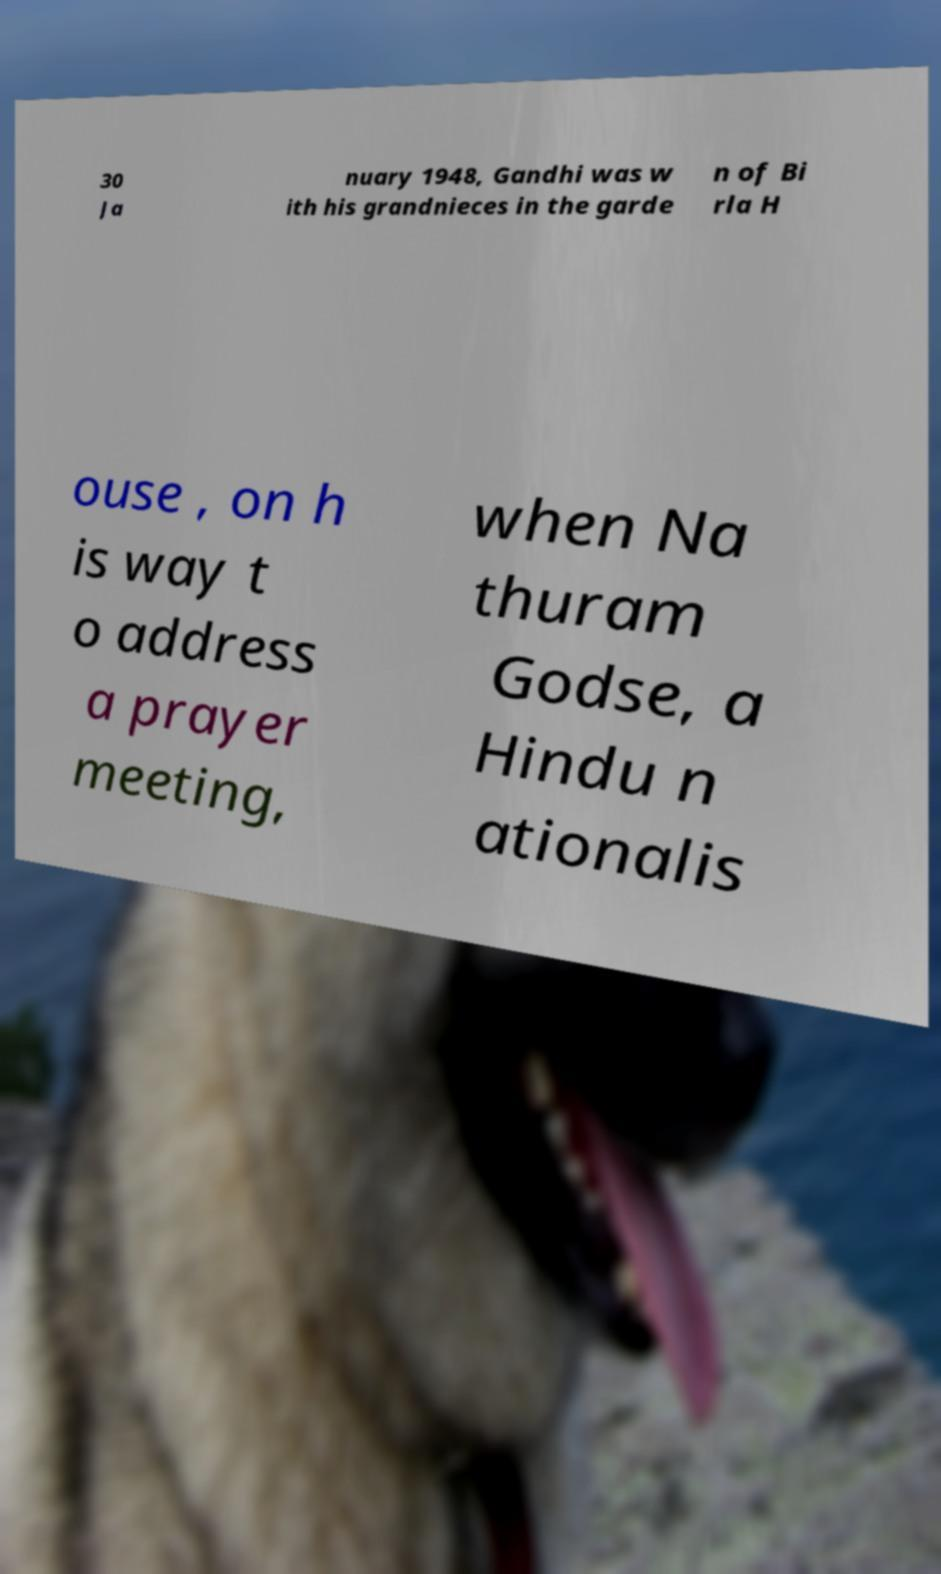For documentation purposes, I need the text within this image transcribed. Could you provide that? 30 Ja nuary 1948, Gandhi was w ith his grandnieces in the garde n of Bi rla H ouse , on h is way t o address a prayer meeting, when Na thuram Godse, a Hindu n ationalis 